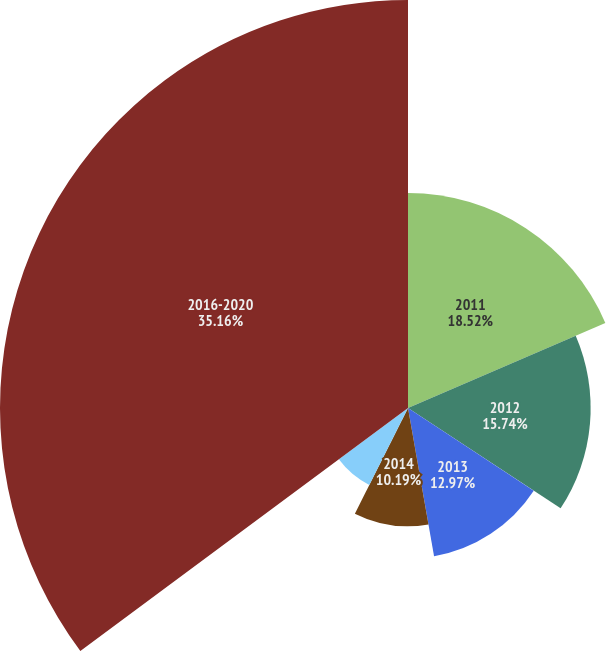<chart> <loc_0><loc_0><loc_500><loc_500><pie_chart><fcel>2011<fcel>2012<fcel>2013<fcel>2014<fcel>2015<fcel>2016-2020<nl><fcel>18.52%<fcel>15.74%<fcel>12.97%<fcel>10.19%<fcel>7.42%<fcel>35.16%<nl></chart> 